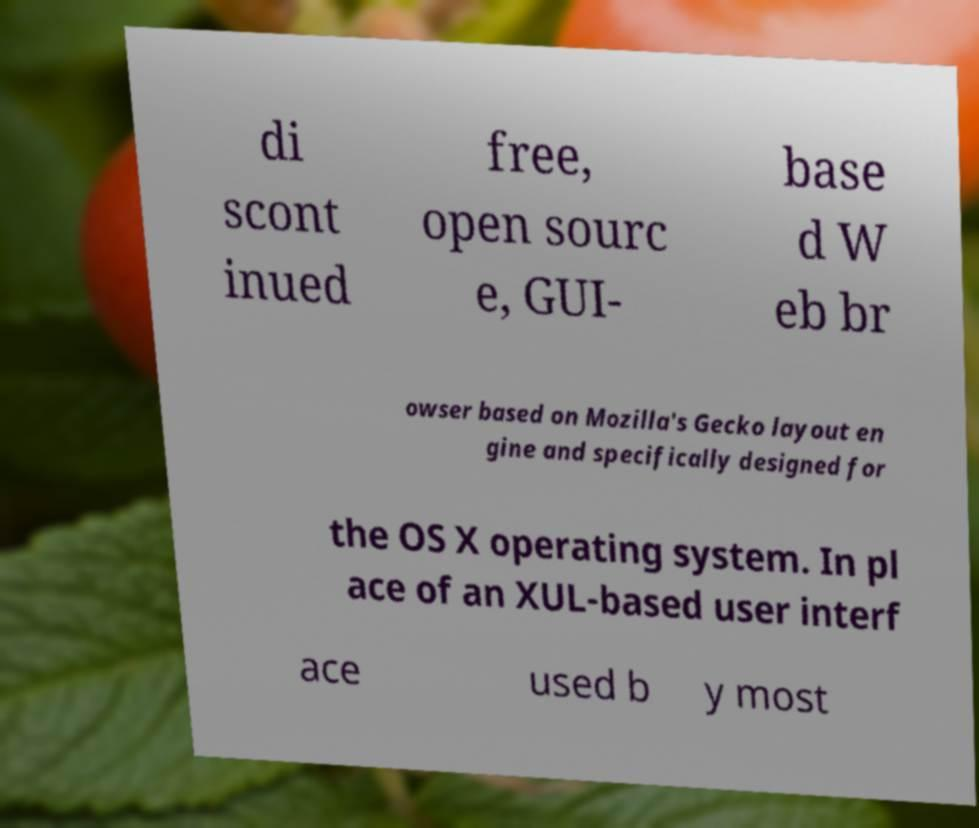For documentation purposes, I need the text within this image transcribed. Could you provide that? di scont inued free, open sourc e, GUI- base d W eb br owser based on Mozilla's Gecko layout en gine and specifically designed for the OS X operating system. In pl ace of an XUL-based user interf ace used b y most 